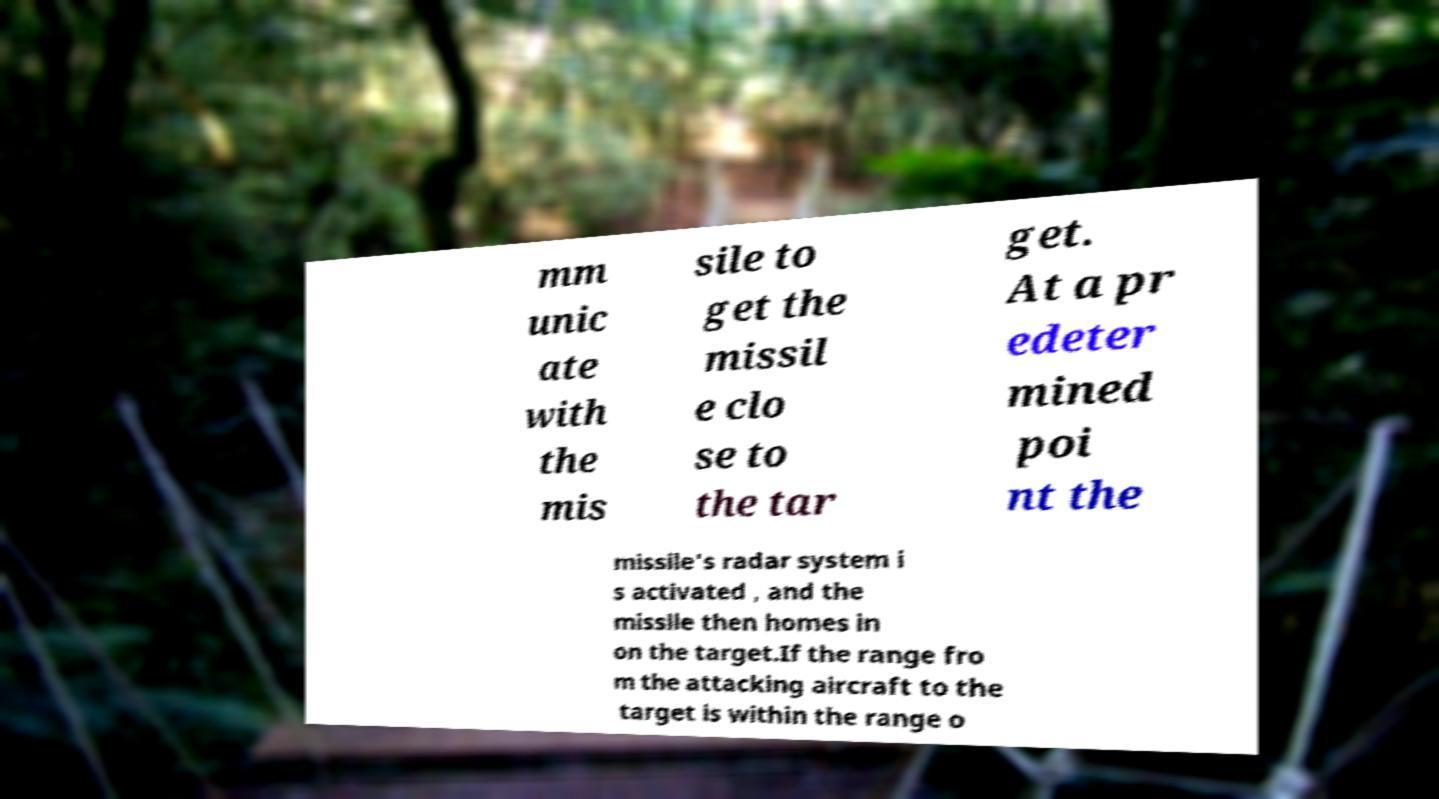I need the written content from this picture converted into text. Can you do that? mm unic ate with the mis sile to get the missil e clo se to the tar get. At a pr edeter mined poi nt the missile's radar system i s activated , and the missile then homes in on the target.If the range fro m the attacking aircraft to the target is within the range o 